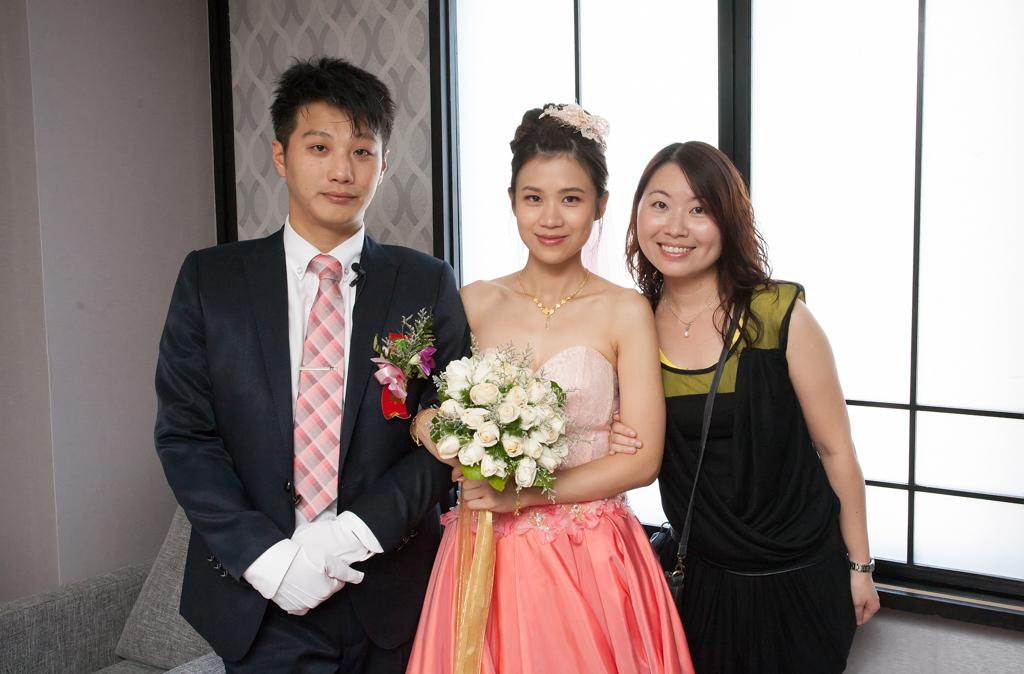How many people are in the image? There are two women and a man in the image, making a total of three people. What is one of the women holding? One of the women is holding a bouquet. What can be seen in the background of the image? There is a window visible in the background of the image. What type of boundary can be seen in the image? There is no boundary visible in the image. How many quarters are present in the image? There are no quarters present in the image. 